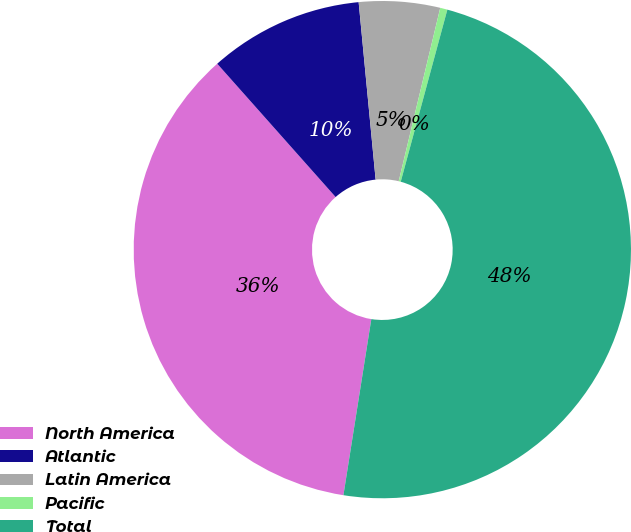Convert chart to OTSL. <chart><loc_0><loc_0><loc_500><loc_500><pie_chart><fcel>North America<fcel>Atlantic<fcel>Latin America<fcel>Pacific<fcel>Total<nl><fcel>35.94%<fcel>10.04%<fcel>5.26%<fcel>0.47%<fcel>48.29%<nl></chart> 